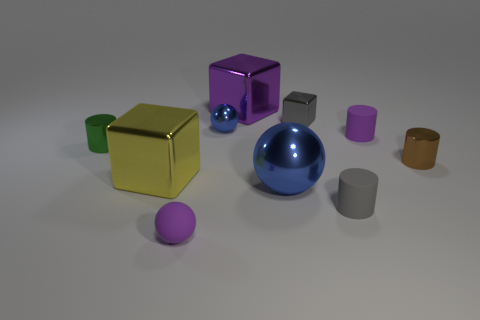Subtract all big purple metallic cubes. How many cubes are left? 2 Subtract all purple balls. How many balls are left? 2 Subtract all cylinders. How many objects are left? 6 Subtract 1 blocks. How many blocks are left? 2 Subtract all cyan cubes. Subtract all purple cylinders. How many cubes are left? 3 Subtract all purple cubes. How many cyan balls are left? 0 Subtract all small red shiny objects. Subtract all blue objects. How many objects are left? 8 Add 3 spheres. How many spheres are left? 6 Add 10 large brown objects. How many large brown objects exist? 10 Subtract 0 red cubes. How many objects are left? 10 